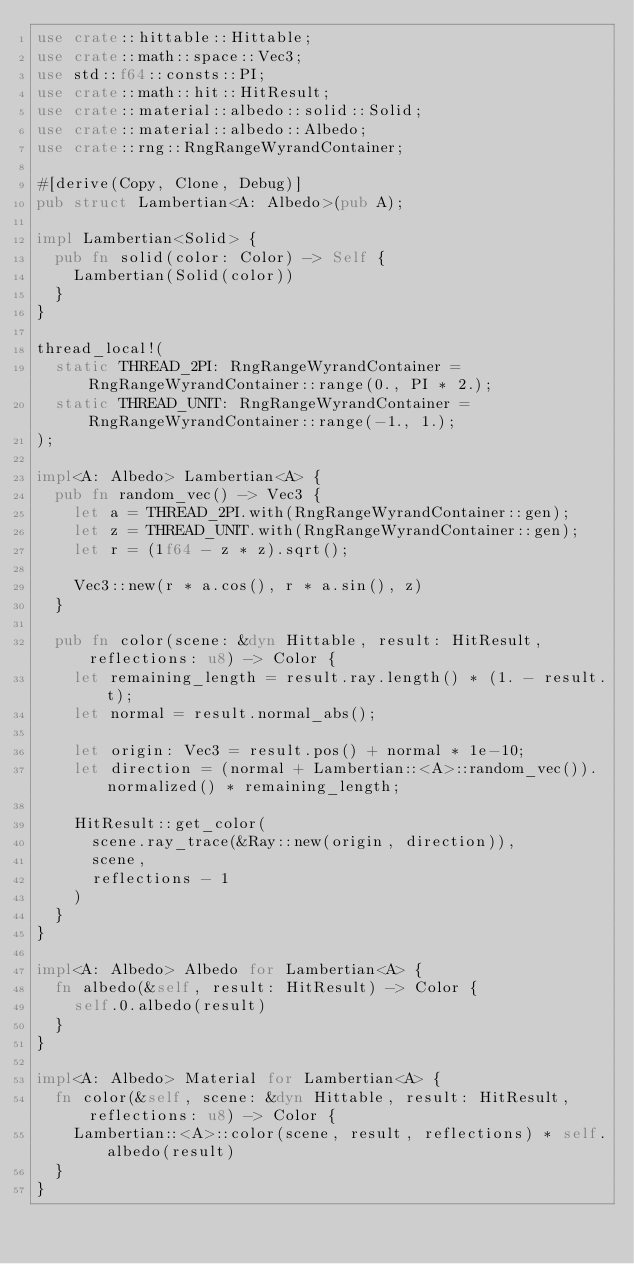<code> <loc_0><loc_0><loc_500><loc_500><_Rust_>use crate::hittable::Hittable;
use crate::math::space::Vec3;
use std::f64::consts::PI;
use crate::math::hit::HitResult;
use crate::material::albedo::solid::Solid;
use crate::material::albedo::Albedo;
use crate::rng::RngRangeWyrandContainer;

#[derive(Copy, Clone, Debug)]
pub struct Lambertian<A: Albedo>(pub A);

impl Lambertian<Solid> {
	pub fn solid(color: Color) -> Self {
		Lambertian(Solid(color))
	}
}

thread_local!(
	static THREAD_2PI: RngRangeWyrandContainer = RngRangeWyrandContainer::range(0., PI * 2.);
	static THREAD_UNIT: RngRangeWyrandContainer = RngRangeWyrandContainer::range(-1., 1.);
);

impl<A: Albedo> Lambertian<A> {
	pub fn random_vec() -> Vec3 {
		let a = THREAD_2PI.with(RngRangeWyrandContainer::gen);
		let z = THREAD_UNIT.with(RngRangeWyrandContainer::gen);
		let r = (1f64 - z * z).sqrt();

		Vec3::new(r * a.cos(), r * a.sin(), z)
	}

	pub fn color(scene: &dyn Hittable, result: HitResult, reflections: u8) -> Color {
		let remaining_length = result.ray.length() * (1. - result.t);
		let normal = result.normal_abs();

		let origin: Vec3 = result.pos() + normal * 1e-10;
		let direction = (normal + Lambertian::<A>::random_vec()).normalized() * remaining_length;

		HitResult::get_color(
			scene.ray_trace(&Ray::new(origin, direction)),
			scene,
			reflections - 1
		)
	}
}

impl<A: Albedo> Albedo for Lambertian<A> {
	fn albedo(&self, result: HitResult) -> Color {
		self.0.albedo(result)
	}
}

impl<A: Albedo> Material for Lambertian<A> {
	fn color(&self, scene: &dyn Hittable, result: HitResult, reflections: u8) -> Color {
		Lambertian::<A>::color(scene, result, reflections) * self.albedo(result)
	}
}
</code> 